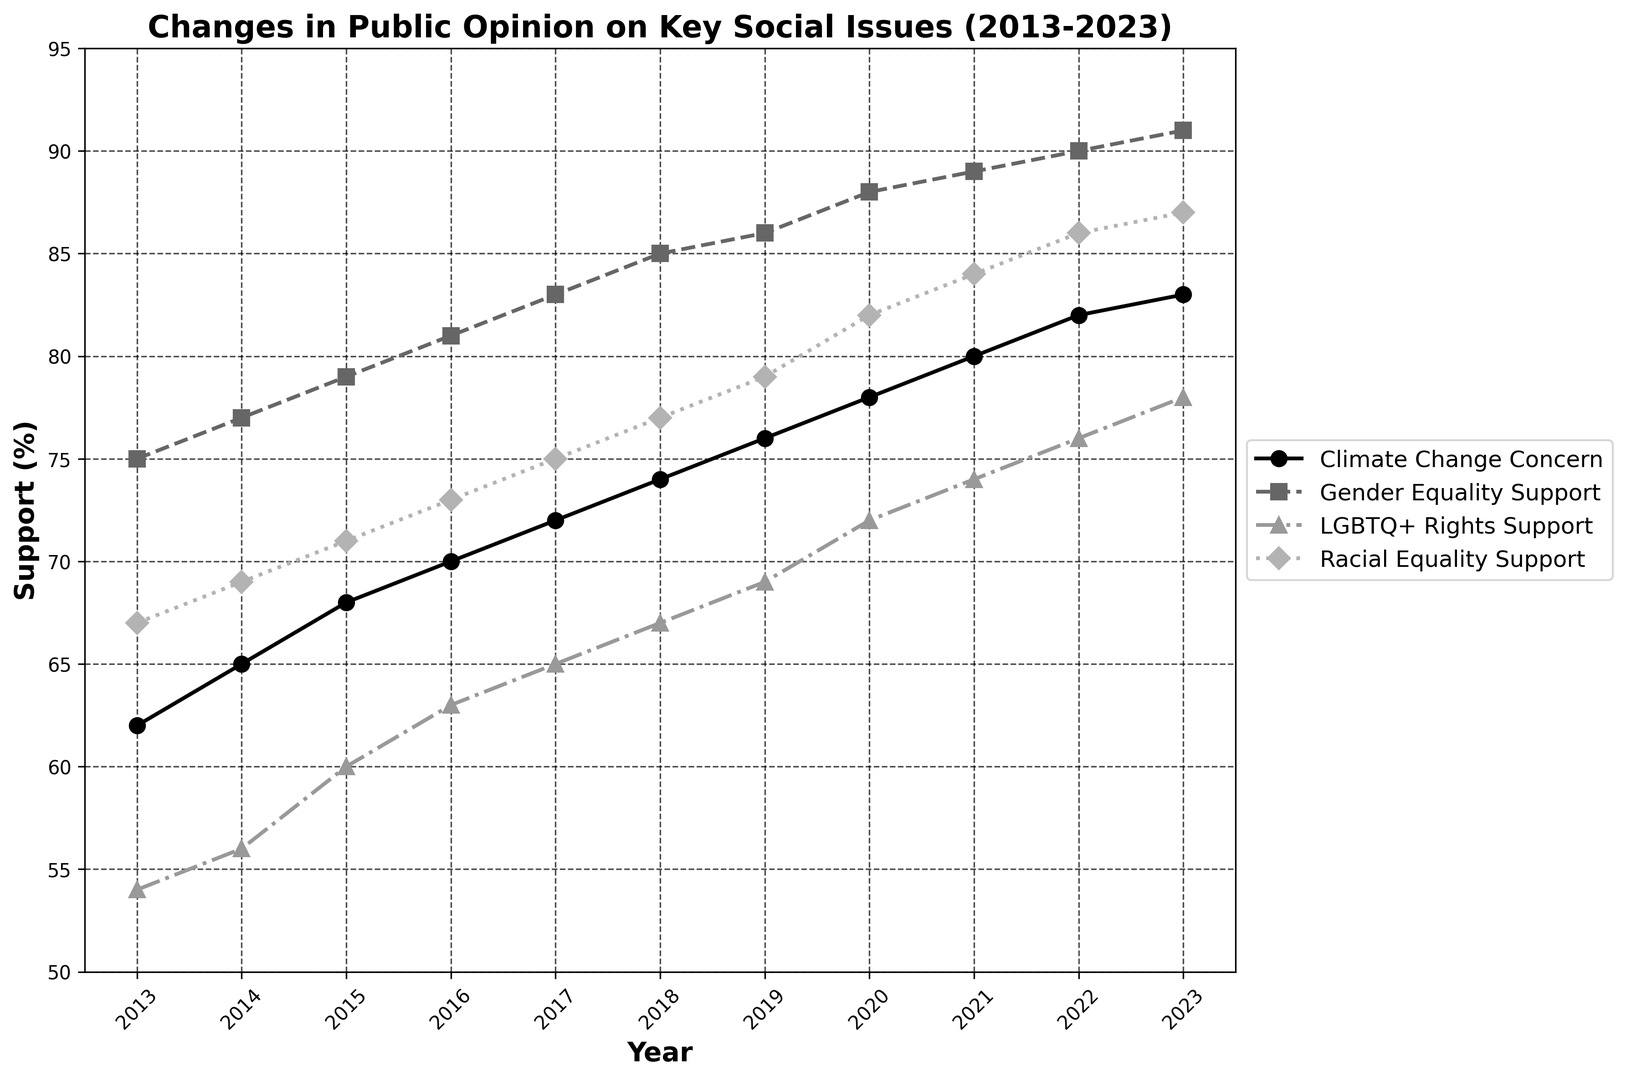What is the trend for public concern for climate change from 2013 to 2023? The trend can be identified by looking at the line chart for the "Climate Change Concern". The line starts at 62% in 2013 and increases each year, reaching 83% in 2023. This consistent upward movement indicates a rising trend in public concern for climate change.
Answer: Increasing In which year did public support for LGBTQ+ rights surpass 70%? Locate the "LGBTQ+ Rights Support" line and identify when it reaches or exceeds 70%. The figure shows that this happens in 2020 when support is at 72%.
Answer: 2020 Which issue had the lowest public support in 2013? Compare the starting points of all the lines in 2013. "LGBTQ+ Rights Support" has the lowest starting value at 54%, while others are at 62%, 75%, and 67%.
Answer: LGBTQ+ Rights Support Which social issue had the greatest increase in public support from 2013 to 2023? Calculate the change by subtracting the 2013 values from the 2023 values for each issue. The changes are: Climate Change Concern (83-62=21), Gender Equality Support (91-75=16), LGBTQ+ Rights Support (78-54=24), Racial Equality Support (87-67=20). LGBTQ+ Rights Support has the greatest increase (24%).
Answer: LGBTQ+ Rights Support What was the average support for racial equality across the entire decade? Sum the values from 2013 to 2023 and divide by 11. The sum is (67 + 69 + 71 + 73 + 75 + 77 + 79 + 82 + 84 + 86 + 87) = 850. The average is 850/11 = 77.27.
Answer: 77.27% Which year had the highest combined level of support across all four issues? Add the support levels for each issue per year: e.g., for 2023, (83 + 91 + 78 + 87 = 339), then compare all years. 2023 has the highest combined support.
Answer: 2023 Was there any year where the public concern for climate change did not increase compared to the previous year? Analyze the "Climate Change Concern" line year by year. It consistently increases every year from 2013 to 2023.
Answer: No By what percentage did support for gender equality grow from 2017 to 2023? Calculate the difference and then divide by the 2017 value, multiplying by 100 to get the percentage. ((91-83)/83)*100 = 19.23%.
Answer: 21.67% Compare the level of support for racial equality and LGBTQ+ rights in 2022. Which one was higher? By how much? Look at the 2022 data points: Racial Equality Support is 86%, and LGBTQ+ Rights Support is 76%. Hence, Racial Equality Support is higher by 10%.
Answer: Racial Equality Support by 10% 